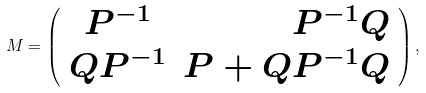Convert formula to latex. <formula><loc_0><loc_0><loc_500><loc_500>M = \left ( \begin{array} { c r c } P ^ { - 1 } & P ^ { - 1 } Q \\ Q P ^ { - 1 } & P + Q P ^ { - 1 } Q \\ \end{array} \right ) ,</formula> 